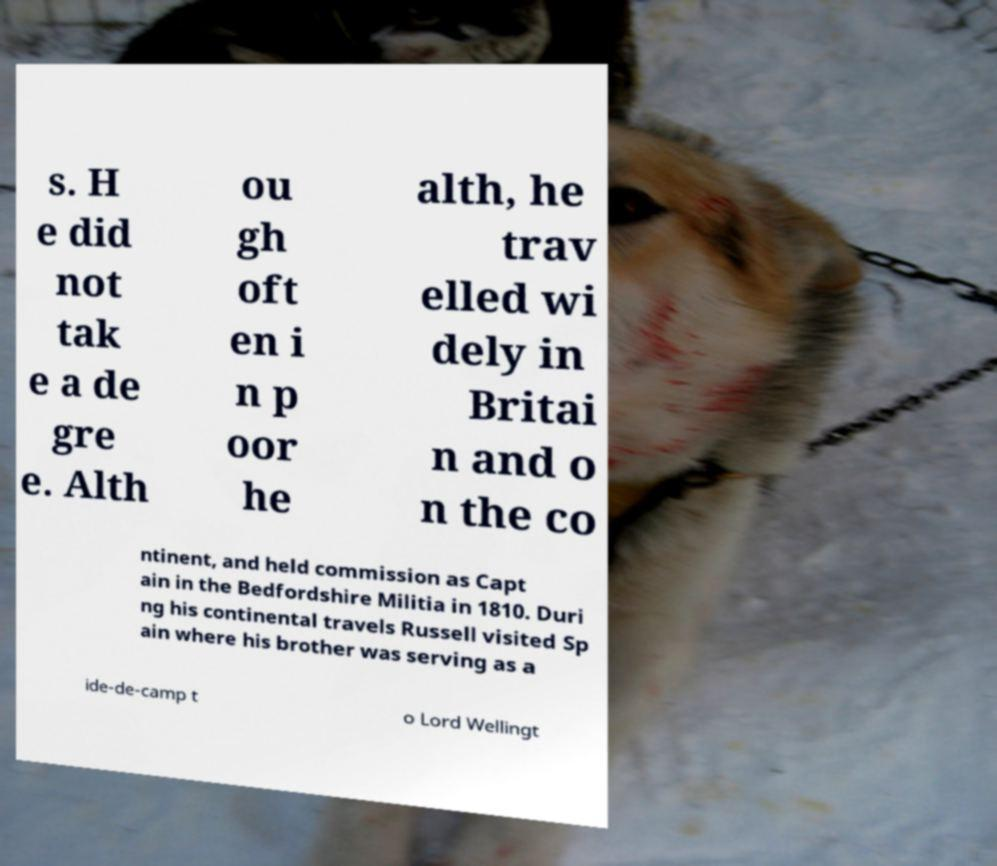Can you accurately transcribe the text from the provided image for me? s. H e did not tak e a de gre e. Alth ou gh oft en i n p oor he alth, he trav elled wi dely in Britai n and o n the co ntinent, and held commission as Capt ain in the Bedfordshire Militia in 1810. Duri ng his continental travels Russell visited Sp ain where his brother was serving as a ide-de-camp t o Lord Wellingt 